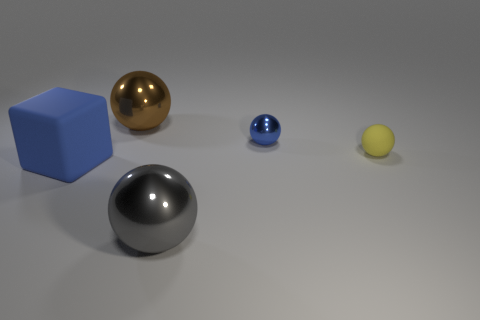Add 1 blue spheres. How many objects exist? 6 Subtract all rubber spheres. How many spheres are left? 3 Subtract 1 yellow balls. How many objects are left? 4 Subtract all balls. How many objects are left? 1 Subtract 3 spheres. How many spheres are left? 1 Subtract all green spheres. Subtract all green blocks. How many spheres are left? 4 Subtract all green cylinders. How many red balls are left? 0 Subtract all yellow metal spheres. Subtract all blue metal spheres. How many objects are left? 4 Add 3 small things. How many small things are left? 5 Add 3 blue objects. How many blue objects exist? 5 